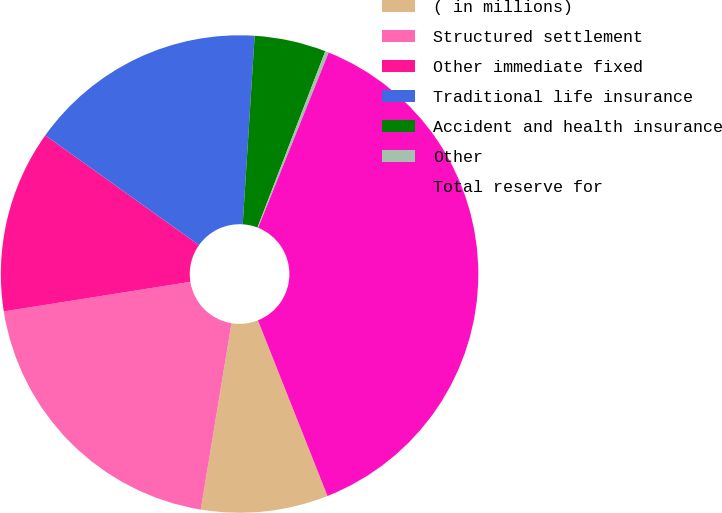Convert chart to OTSL. <chart><loc_0><loc_0><loc_500><loc_500><pie_chart><fcel>( in millions)<fcel>Structured settlement<fcel>Other immediate fixed<fcel>Traditional life insurance<fcel>Accident and health insurance<fcel>Other<fcel>Total reserve for<nl><fcel>8.6%<fcel>19.9%<fcel>12.37%<fcel>16.14%<fcel>4.84%<fcel>0.24%<fcel>37.91%<nl></chart> 